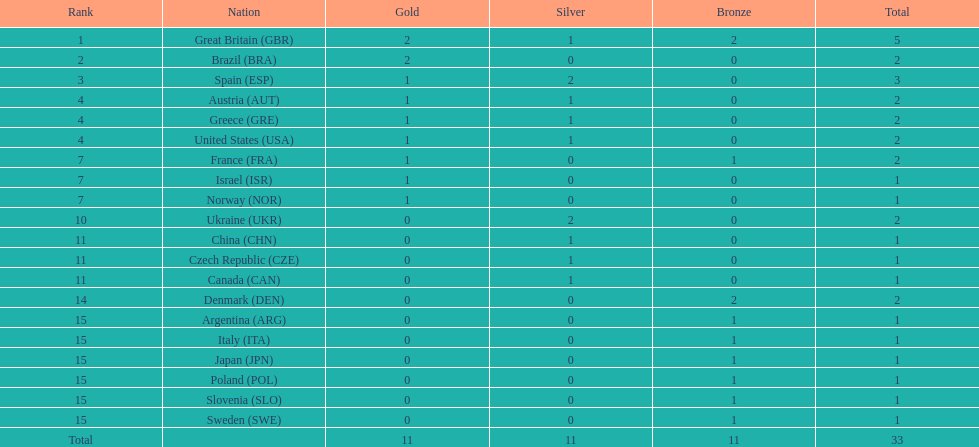What was the number of silver medals won by ukraine? 2. 